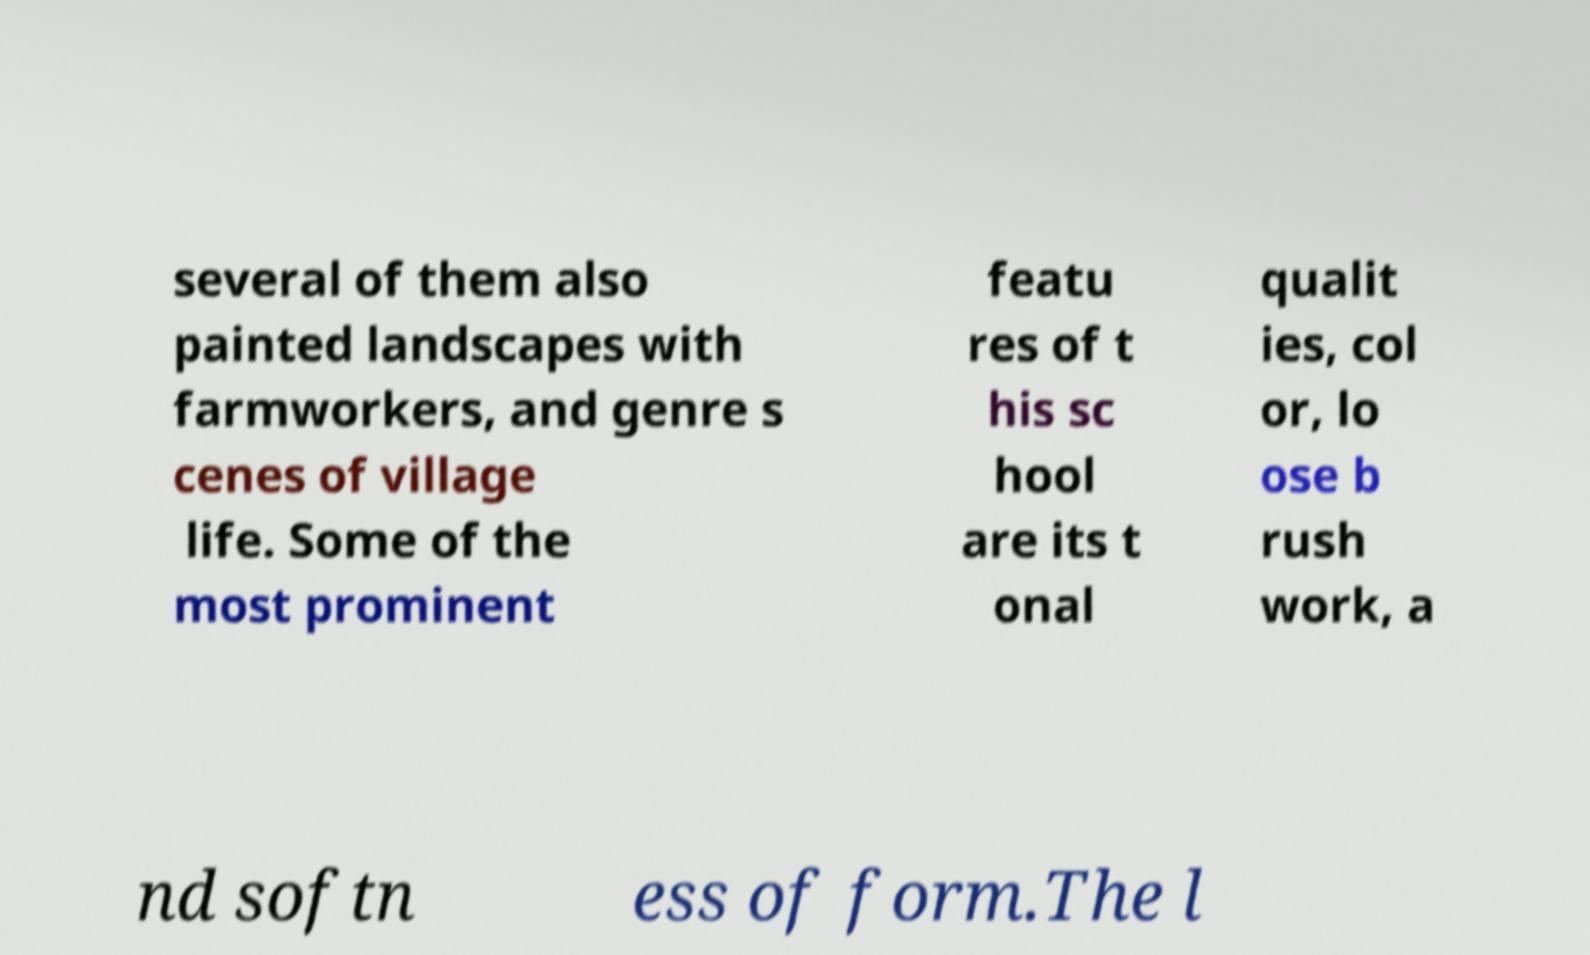Can you accurately transcribe the text from the provided image for me? several of them also painted landscapes with farmworkers, and genre s cenes of village life. Some of the most prominent featu res of t his sc hool are its t onal qualit ies, col or, lo ose b rush work, a nd softn ess of form.The l 